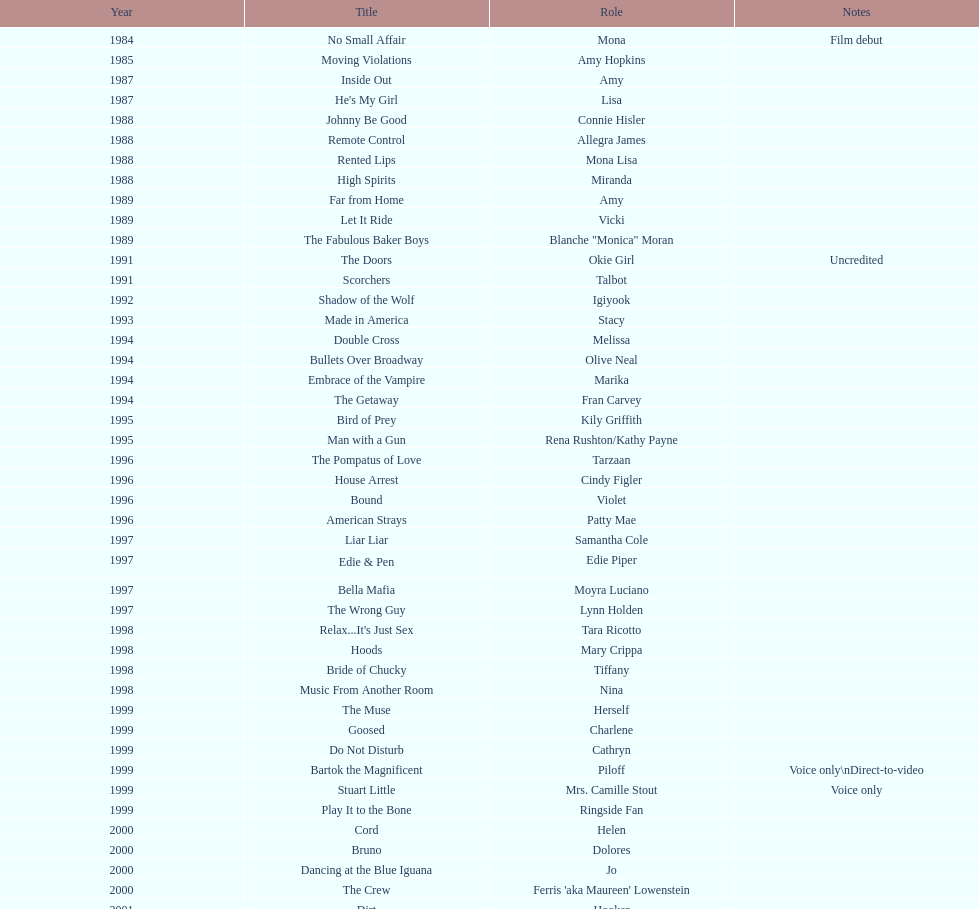In what number of films has jennifer tilly performed as a voice-over artist? 5. 